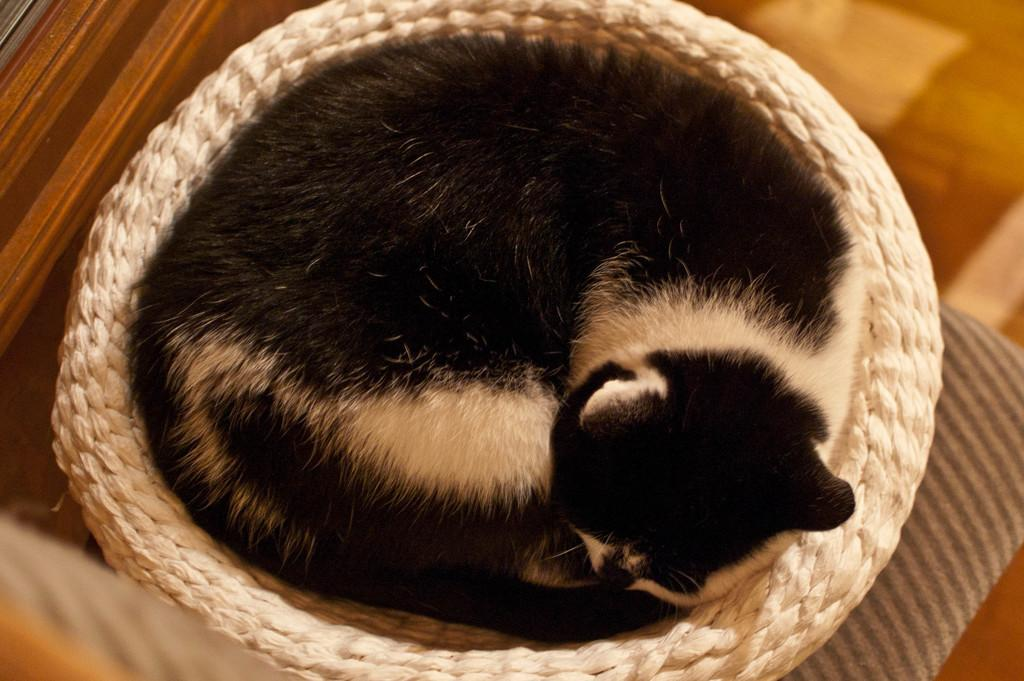What type of animal can be seen in the image? There is an animal visible in the image, but its specific type cannot be determined from the provided facts. Where is the animal located in the image? The animal is on a basket in the image. What is the position of the basket in the image? The basket is kept on the floor in the image. What type of twig is the animal using to build a tent in the image? There is no twig or tent present in the image; the animal is on a basket that is kept on the floor. 